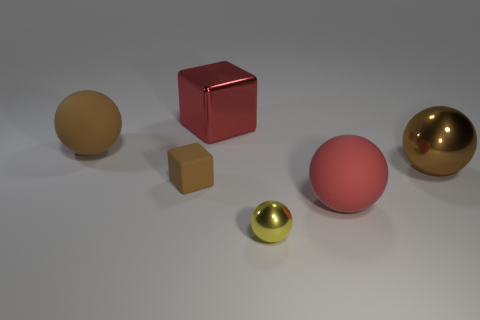Subtract 1 balls. How many balls are left? 3 Subtract all large metallic balls. How many balls are left? 3 Subtract all yellow spheres. How many spheres are left? 3 Subtract all blue spheres. Subtract all green blocks. How many spheres are left? 4 Add 1 large shiny cubes. How many objects exist? 7 Subtract all blocks. How many objects are left? 4 Subtract 0 purple blocks. How many objects are left? 6 Subtract all small cubes. Subtract all red cubes. How many objects are left? 4 Add 6 tiny brown things. How many tiny brown things are left? 7 Add 5 large objects. How many large objects exist? 9 